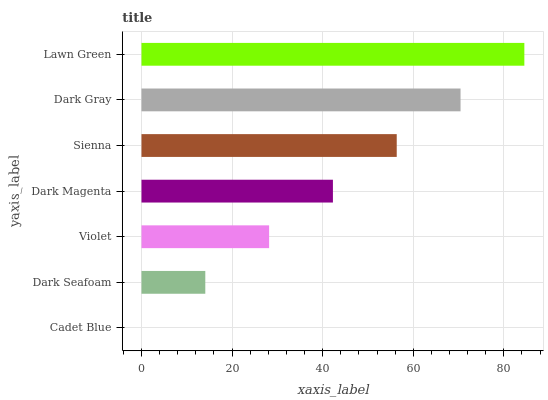Is Cadet Blue the minimum?
Answer yes or no. Yes. Is Lawn Green the maximum?
Answer yes or no. Yes. Is Dark Seafoam the minimum?
Answer yes or no. No. Is Dark Seafoam the maximum?
Answer yes or no. No. Is Dark Seafoam greater than Cadet Blue?
Answer yes or no. Yes. Is Cadet Blue less than Dark Seafoam?
Answer yes or no. Yes. Is Cadet Blue greater than Dark Seafoam?
Answer yes or no. No. Is Dark Seafoam less than Cadet Blue?
Answer yes or no. No. Is Dark Magenta the high median?
Answer yes or no. Yes. Is Dark Magenta the low median?
Answer yes or no. Yes. Is Lawn Green the high median?
Answer yes or no. No. Is Sienna the low median?
Answer yes or no. No. 